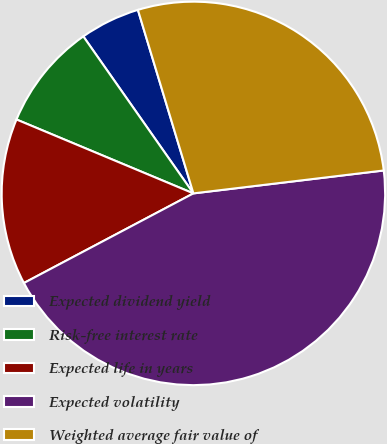Convert chart. <chart><loc_0><loc_0><loc_500><loc_500><pie_chart><fcel>Expected dividend yield<fcel>Risk-free interest rate<fcel>Expected life in years<fcel>Expected volatility<fcel>Weighted average fair value of<nl><fcel>5.06%<fcel>8.97%<fcel>14.04%<fcel>44.17%<fcel>27.77%<nl></chart> 